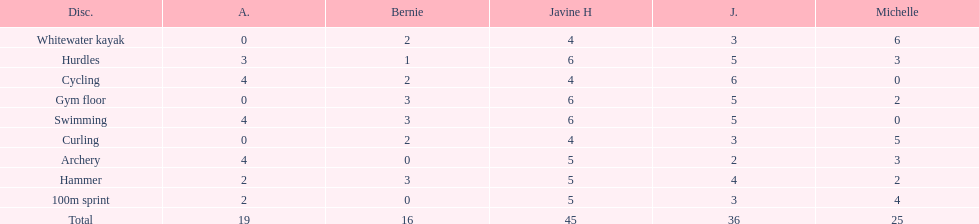What is the average score on 100m sprint? 2.8. 